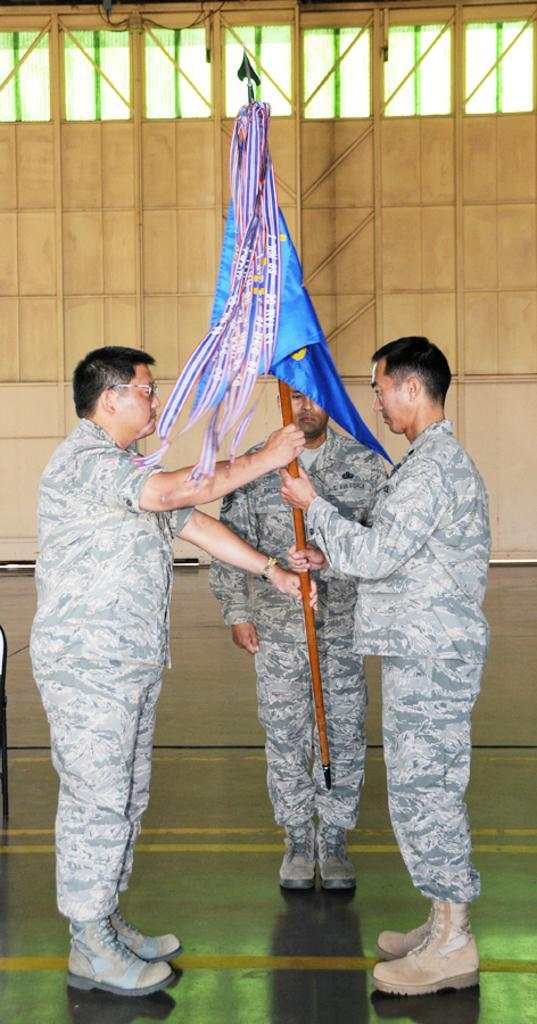Please provide a concise description of this image. In this picture there are two persons standing and holding the flag and there is a person standing. At the back there is a wall. At the top it looks like windows. At the bottom there is a floor. 